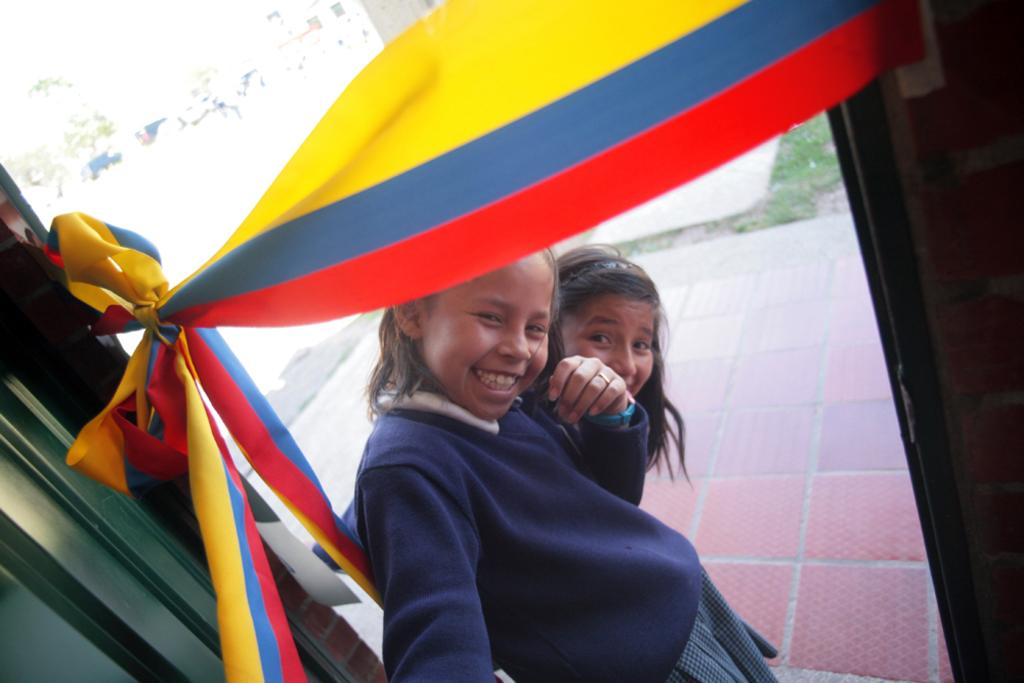How many people are in the image? There are two persons in the image. What can be seen near the persons in the image? There is a ribbon with three colors in the image. What type of structure is visible in the image? There is an entrance to a house in the image. What is the landscape like in the image? There is a grassy land and a tree in the image. What type of plants can be seen growing in a square shape in the image? There are no plants growing in a square shape in the image. How many bananas are hanging from the tree in the image? There are no bananas visible in the image; only a tree is present. 